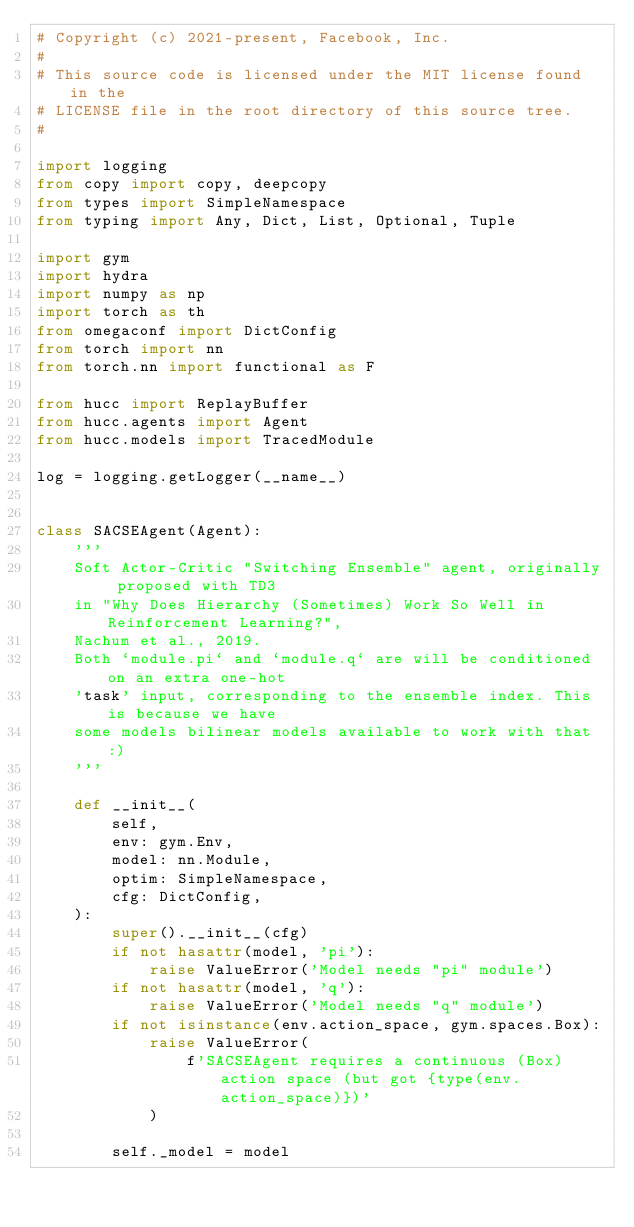Convert code to text. <code><loc_0><loc_0><loc_500><loc_500><_Python_># Copyright (c) 2021-present, Facebook, Inc.
#
# This source code is licensed under the MIT license found in the
# LICENSE file in the root directory of this source tree.
#

import logging
from copy import copy, deepcopy
from types import SimpleNamespace
from typing import Any, Dict, List, Optional, Tuple

import gym
import hydra
import numpy as np
import torch as th
from omegaconf import DictConfig
from torch import nn
from torch.nn import functional as F

from hucc import ReplayBuffer
from hucc.agents import Agent
from hucc.models import TracedModule

log = logging.getLogger(__name__)


class SACSEAgent(Agent):
    '''
    Soft Actor-Critic "Switching Ensemble" agent, originally proposed with TD3
    in "Why Does Hierarchy (Sometimes) Work So Well in Reinforcement Learning?",
    Nachum et al., 2019.
    Both `module.pi` and `module.q` are will be conditioned on an extra one-hot
    'task' input, corresponding to the ensemble index. This is because we have
    some models bilinear models available to work with that :)
    '''

    def __init__(
        self,
        env: gym.Env,
        model: nn.Module,
        optim: SimpleNamespace,
        cfg: DictConfig,
    ):
        super().__init__(cfg)
        if not hasattr(model, 'pi'):
            raise ValueError('Model needs "pi" module')
        if not hasattr(model, 'q'):
            raise ValueError('Model needs "q" module')
        if not isinstance(env.action_space, gym.spaces.Box):
            raise ValueError(
                f'SACSEAgent requires a continuous (Box) action space (but got {type(env.action_space)})'
            )

        self._model = model</code> 